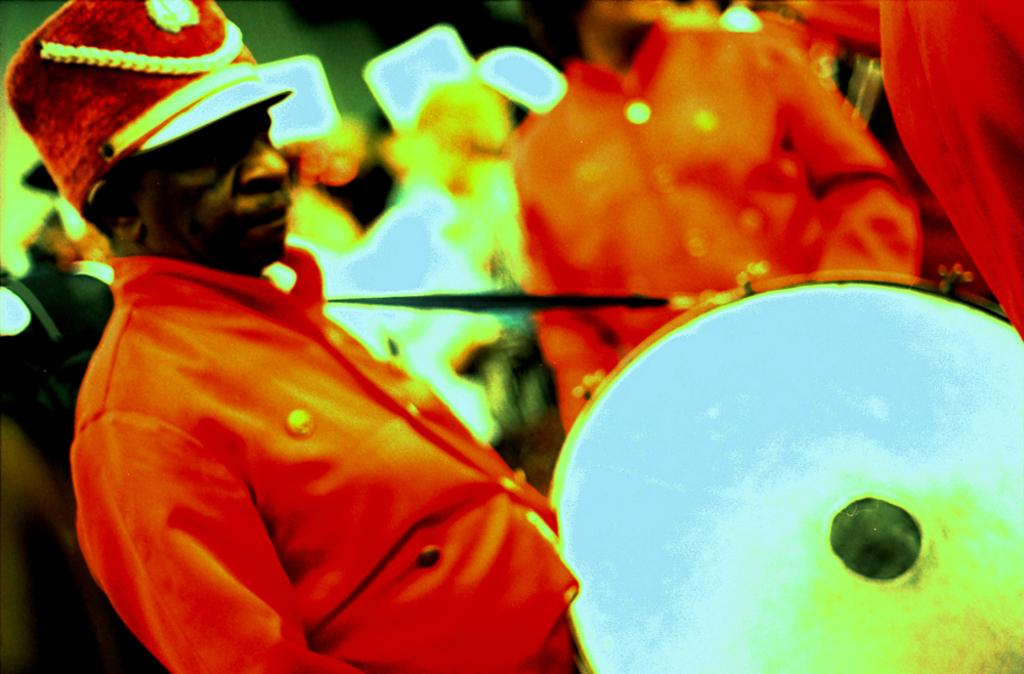What is the main subject of the image? The main subject of the image is a man. Can you describe the man's clothing? The man is wearing an orange color shirt. What is the man holding in the image? The man is wearing a musical instrument. What can be seen in the background of the image? There is a group of people and lights visible in the background of the image. What type of account does the man have with the bean in the image? There is no account or bean present in the image. How does the man care for the bean in the image? There is no bean or indication of the man caring for anything in the image. 